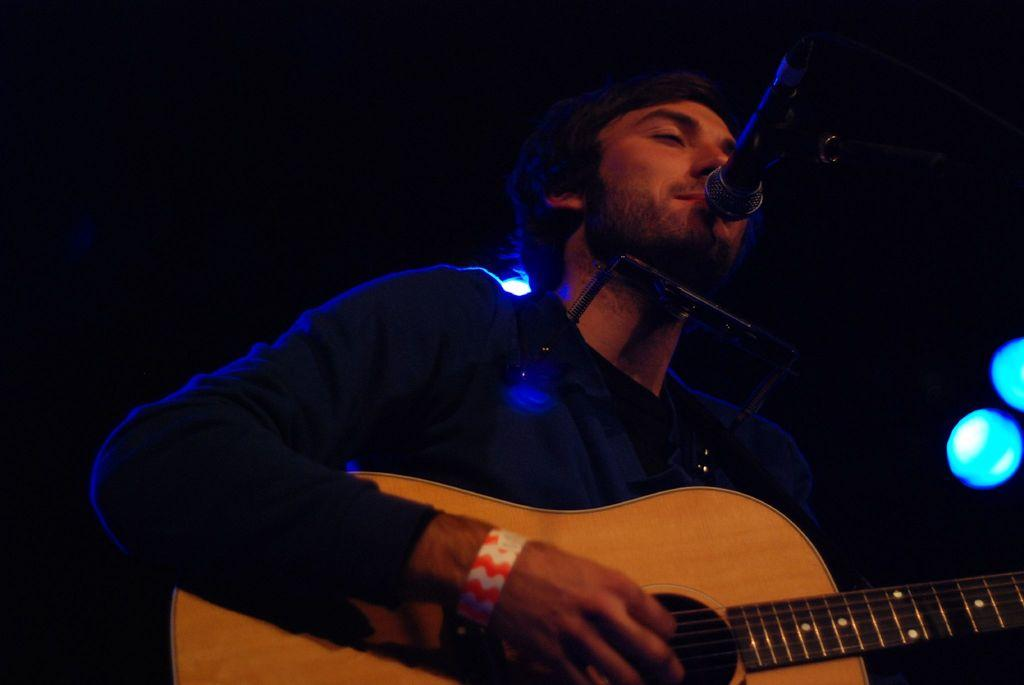What is the person in the image doing? The person is holding a guitar and singing. What object is the person using to amplify their voice? There is a microphone in the image. What type of quince is the person eating in the image? There is no quince present in the image; the person is holding a guitar and singing. 